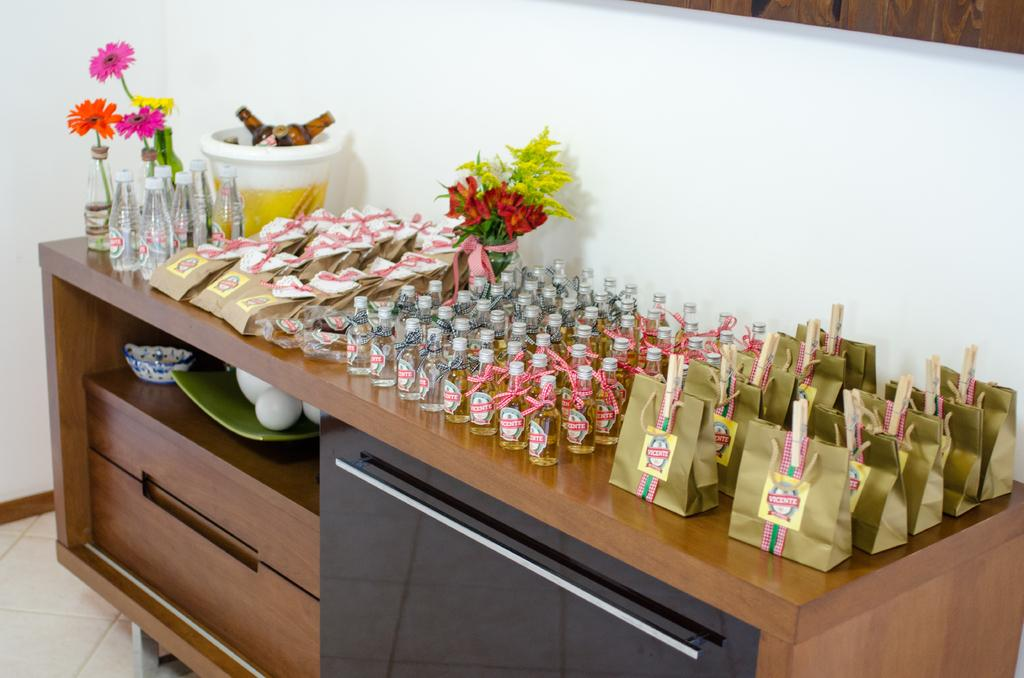What is the main piece of furniture in the image? There is a table in the image. What items are placed on the table? There are wine bottles and covers on the table. How are the covers arranged on the table? The covers are kept in a line on the table. How many servants are present in the image? There is no mention of servants in the image; it only shows a table with wine bottles and covers. 